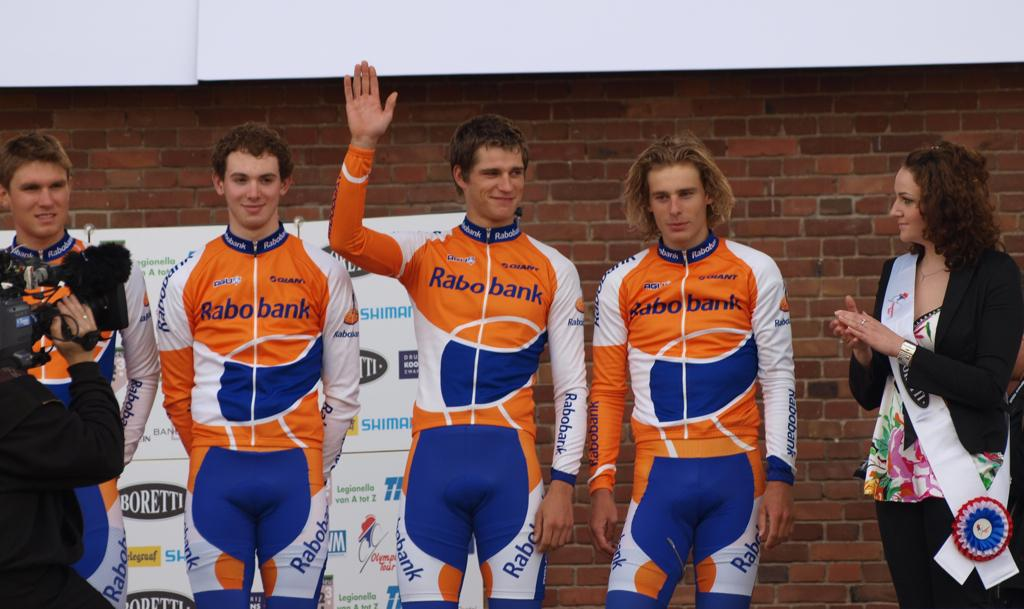<image>
Write a terse but informative summary of the picture. four guys wearing rabobank branded suits being applauded by a woman while someone films 